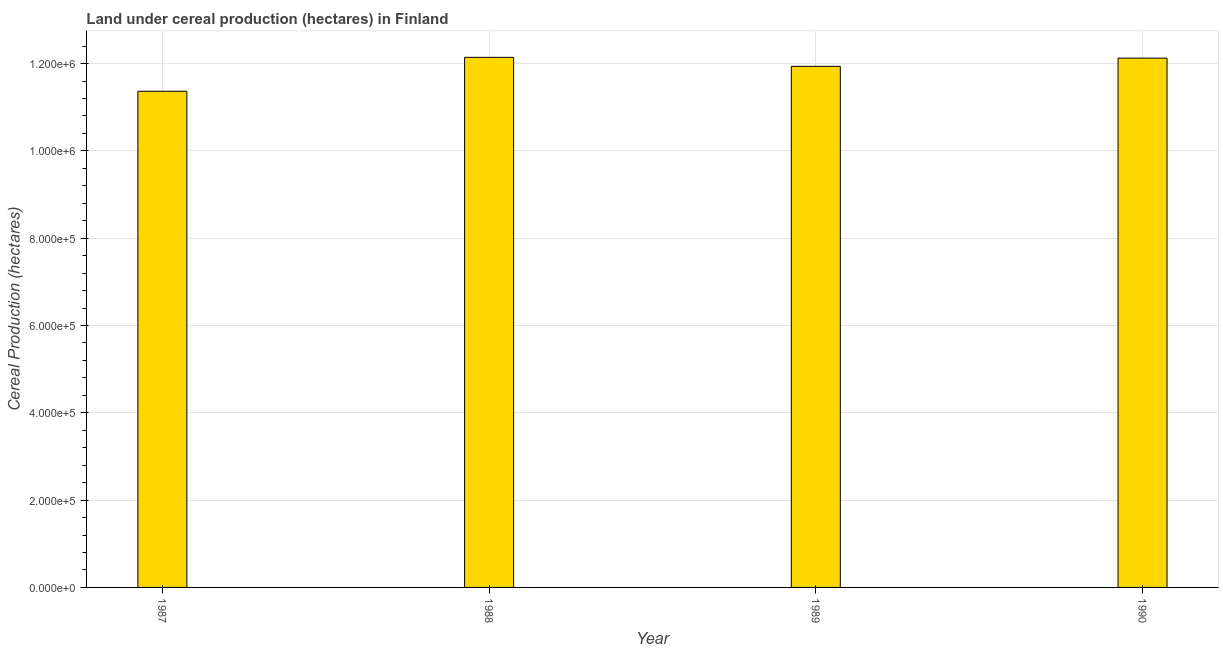Does the graph contain any zero values?
Keep it short and to the point. No. Does the graph contain grids?
Give a very brief answer. Yes. What is the title of the graph?
Make the answer very short. Land under cereal production (hectares) in Finland. What is the label or title of the Y-axis?
Offer a very short reply. Cereal Production (hectares). What is the land under cereal production in 1987?
Offer a very short reply. 1.14e+06. Across all years, what is the maximum land under cereal production?
Your answer should be compact. 1.21e+06. Across all years, what is the minimum land under cereal production?
Your answer should be compact. 1.14e+06. In which year was the land under cereal production minimum?
Make the answer very short. 1987. What is the sum of the land under cereal production?
Your answer should be compact. 4.76e+06. What is the difference between the land under cereal production in 1987 and 1990?
Keep it short and to the point. -7.59e+04. What is the average land under cereal production per year?
Your response must be concise. 1.19e+06. What is the median land under cereal production?
Your answer should be very brief. 1.20e+06. In how many years, is the land under cereal production greater than 1080000 hectares?
Your answer should be very brief. 4. Do a majority of the years between 1990 and 1989 (inclusive) have land under cereal production greater than 920000 hectares?
Your answer should be compact. No. What is the ratio of the land under cereal production in 1989 to that in 1990?
Offer a terse response. 0.98. Is the difference between the land under cereal production in 1988 and 1989 greater than the difference between any two years?
Provide a succinct answer. No. What is the difference between the highest and the second highest land under cereal production?
Provide a short and direct response. 1800. Is the sum of the land under cereal production in 1989 and 1990 greater than the maximum land under cereal production across all years?
Give a very brief answer. Yes. What is the difference between the highest and the lowest land under cereal production?
Make the answer very short. 7.77e+04. In how many years, is the land under cereal production greater than the average land under cereal production taken over all years?
Provide a short and direct response. 3. How many bars are there?
Provide a short and direct response. 4. How many years are there in the graph?
Provide a succinct answer. 4. What is the difference between two consecutive major ticks on the Y-axis?
Provide a short and direct response. 2.00e+05. Are the values on the major ticks of Y-axis written in scientific E-notation?
Make the answer very short. Yes. What is the Cereal Production (hectares) in 1987?
Provide a succinct answer. 1.14e+06. What is the Cereal Production (hectares) in 1988?
Your response must be concise. 1.21e+06. What is the Cereal Production (hectares) in 1989?
Provide a short and direct response. 1.19e+06. What is the Cereal Production (hectares) of 1990?
Your answer should be very brief. 1.21e+06. What is the difference between the Cereal Production (hectares) in 1987 and 1988?
Your answer should be very brief. -7.77e+04. What is the difference between the Cereal Production (hectares) in 1987 and 1989?
Keep it short and to the point. -5.71e+04. What is the difference between the Cereal Production (hectares) in 1987 and 1990?
Your answer should be very brief. -7.59e+04. What is the difference between the Cereal Production (hectares) in 1988 and 1989?
Your answer should be compact. 2.06e+04. What is the difference between the Cereal Production (hectares) in 1988 and 1990?
Offer a very short reply. 1800. What is the difference between the Cereal Production (hectares) in 1989 and 1990?
Keep it short and to the point. -1.88e+04. What is the ratio of the Cereal Production (hectares) in 1987 to that in 1988?
Make the answer very short. 0.94. What is the ratio of the Cereal Production (hectares) in 1987 to that in 1989?
Your response must be concise. 0.95. What is the ratio of the Cereal Production (hectares) in 1987 to that in 1990?
Your answer should be compact. 0.94. What is the ratio of the Cereal Production (hectares) in 1988 to that in 1989?
Keep it short and to the point. 1.02. What is the ratio of the Cereal Production (hectares) in 1988 to that in 1990?
Offer a very short reply. 1. 